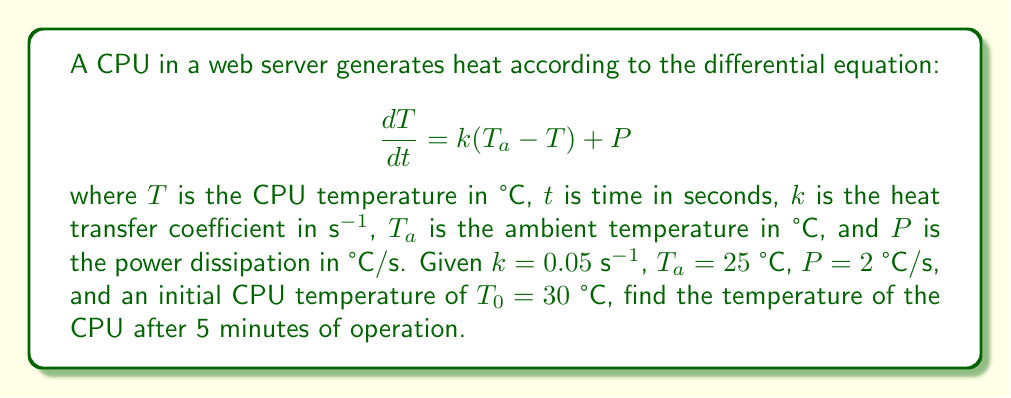Give your solution to this math problem. To solve this first-order linear differential equation, we follow these steps:

1) The general form of the equation is:
   $$\frac{dT}{dt} + kT = kT_a + P$$

2) The integrating factor is $e^{\int k dt} = e^{kt}$

3) Multiplying both sides by the integrating factor:
   $$e^{kt}\frac{dT}{dt} + ke^{kt}T = ke^{kt}T_a + Pe^{kt}$$

4) The left side is now the derivative of $e^{kt}T$:
   $$\frac{d}{dt}(e^{kt}T) = ke^{kt}T_a + Pe^{kt}$$

5) Integrating both sides:
   $$e^{kt}T = kT_a\int e^{kt}dt + P\int e^{kt}dt + C$$
   $$e^{kt}T = kT_a\frac{e^{kt}}{k} + P\frac{e^{kt}}{k} + C$$
   $$T = T_a + \frac{P}{k} + Ce^{-kt}$$

6) Using the initial condition $T(0) = T_0 = 30$ °C:
   $$30 = 25 + \frac{2}{0.05} + C$$
   $$C = 30 - 25 - 40 = -35$$

7) The particular solution is:
   $$T = 25 + 40 - 35e^{-0.05t}$$

8) After 5 minutes (300 seconds):
   $$T(300) = 25 + 40 - 35e^{-0.05(300)}$$
   $$T(300) = 65 - 35e^{-15}$$
   $$T(300) \approx 64.999999999 \text{ °C}$$
Answer: The temperature of the CPU after 5 minutes of operation is approximately 65 °C. 